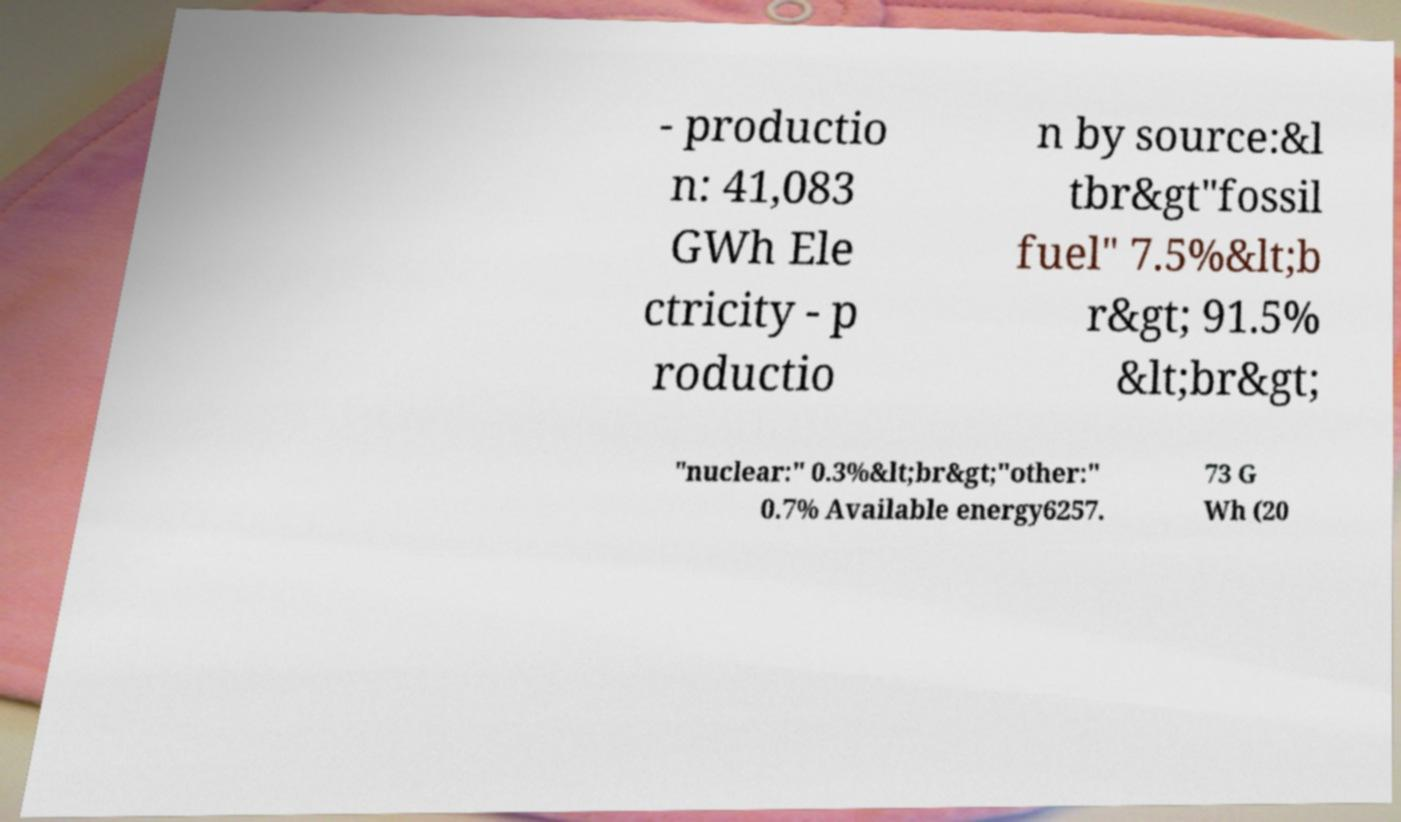For documentation purposes, I need the text within this image transcribed. Could you provide that? - productio n: 41,083 GWh Ele ctricity - p roductio n by source:&l tbr&gt"fossil fuel" 7.5%&lt;b r&gt; 91.5% &lt;br&gt; "nuclear:" 0.3%&lt;br&gt;"other:" 0.7% Available energy6257. 73 G Wh (20 